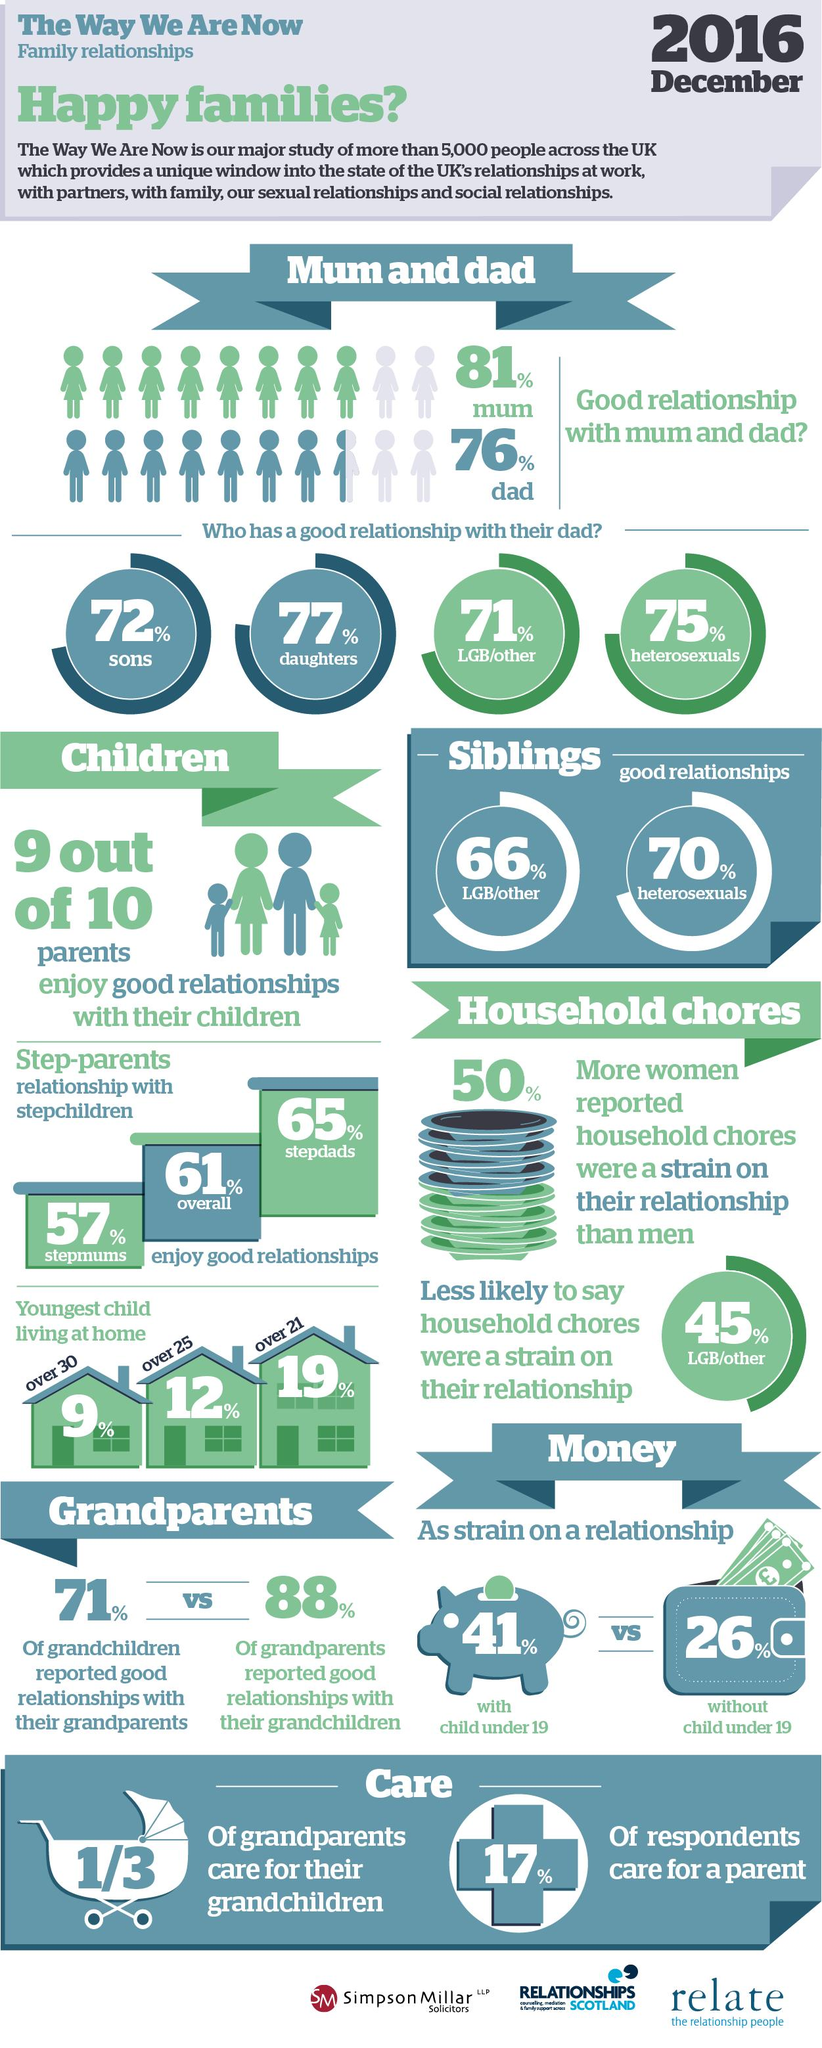Mention a couple of crucial points in this snapshot. It is generally observed that daughters tend to have better relationships with their fathers compared to sons. Heterosexuals who enjoy good relationships with their siblings tend to be happier and more satisfied with their family dynamics. According to the data, 33.33% of grandparents are responsible for caring for their grandchildren. The person who enjoys the best relationship with their stepchildren is usually the stepfather. According to a recent survey, 90% of parents report enjoying good relationships with their children. 